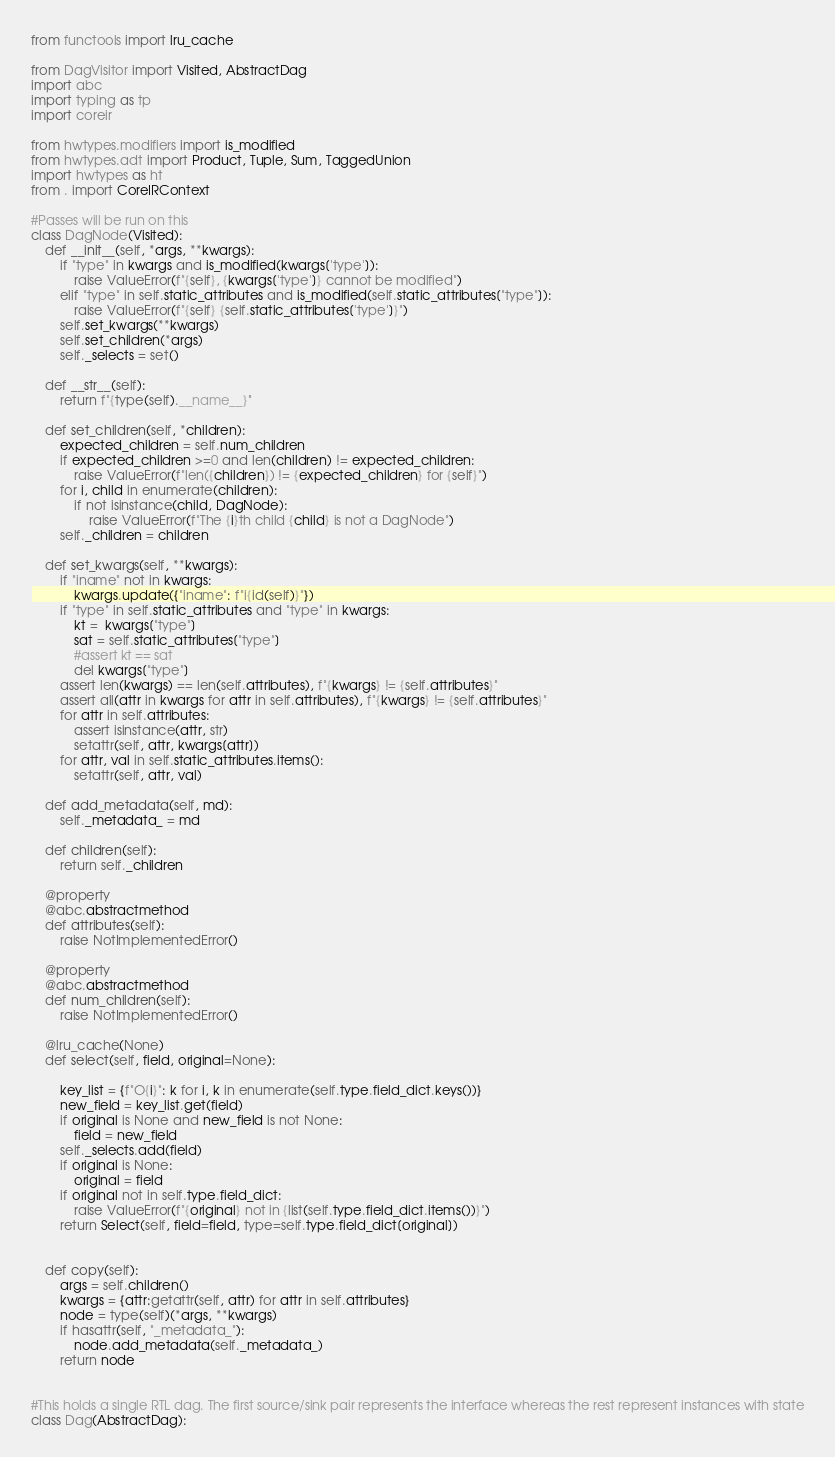<code> <loc_0><loc_0><loc_500><loc_500><_Python_>from functools import lru_cache

from DagVisitor import Visited, AbstractDag
import abc
import typing as tp
import coreir

from hwtypes.modifiers import is_modified
from hwtypes.adt import Product, Tuple, Sum, TaggedUnion
import hwtypes as ht
from . import CoreIRContext

#Passes will be run on this
class DagNode(Visited):
    def __init__(self, *args, **kwargs):
        if "type" in kwargs and is_modified(kwargs['type']):
            raise ValueError(f"{self}, {kwargs['type']} cannot be modified")
        elif "type" in self.static_attributes and is_modified(self.static_attributes["type"]):
            raise ValueError(f"{self} {self.static_attributes['type']}")
        self.set_kwargs(**kwargs)
        self.set_children(*args)
        self._selects = set()

    def __str__(self):
        return f"{type(self).__name__}"

    def set_children(self, *children):
        expected_children = self.num_children
        if expected_children >=0 and len(children) != expected_children:
            raise ValueError(f"len({children}) != {expected_children} for {self}")
        for i, child in enumerate(children):
            if not isinstance(child, DagNode):
                raise ValueError(f"The {i}th child {child} is not a DagNode")
        self._children = children

    def set_kwargs(self, **kwargs):
        if "iname" not in kwargs:
            kwargs.update({"iname": f"i{id(self)}"})
        if "type" in self.static_attributes and "type" in kwargs:
            kt =  kwargs["type"]
            sat = self.static_attributes["type"]
            #assert kt == sat
            del kwargs["type"]
        assert len(kwargs) == len(self.attributes), f"{kwargs} != {self.attributes}"
        assert all(attr in kwargs for attr in self.attributes), f"{kwargs} != {self.attributes}"
        for attr in self.attributes:
            assert isinstance(attr, str)
            setattr(self, attr, kwargs[attr])
        for attr, val in self.static_attributes.items():
            setattr(self, attr, val)

    def add_metadata(self, md):
        self._metadata_ = md

    def children(self):
        return self._children

    @property
    @abc.abstractmethod
    def attributes(self):
        raise NotImplementedError()

    @property
    @abc.abstractmethod
    def num_children(self):
        raise NotImplementedError()

    @lru_cache(None)
    def select(self, field, original=None):

        key_list = {f"O{i}": k for i, k in enumerate(self.type.field_dict.keys())}
        new_field = key_list.get(field)
        if original is None and new_field is not None:
            field = new_field
        self._selects.add(field)
        if original is None:
            original = field
        if original not in self.type.field_dict:
            raise ValueError(f"{original} not in {list(self.type.field_dict.items())}")
        return Select(self, field=field, type=self.type.field_dict[original])


    def copy(self):
        args = self.children()
        kwargs = {attr:getattr(self, attr) for attr in self.attributes}
        node = type(self)(*args, **kwargs)
        if hasattr(self, "_metadata_"):
            node.add_metadata(self._metadata_)
        return node


#This holds a single RTL dag. The first source/sink pair represents the interface whereas the rest represent instances with state
class Dag(AbstractDag):</code> 